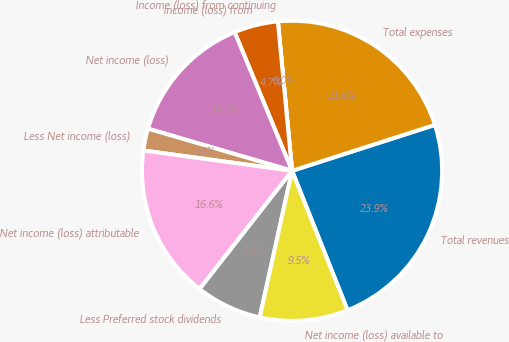Convert chart to OTSL. <chart><loc_0><loc_0><loc_500><loc_500><pie_chart><fcel>Total revenues<fcel>Total expenses<fcel>Income (loss) from continuing<fcel>Income (loss) from<fcel>Net income (loss)<fcel>Less Net income (loss)<fcel>Net income (loss) attributable<fcel>Less Preferred stock dividends<fcel>Net income (loss) available to<nl><fcel>23.92%<fcel>21.55%<fcel>0.0%<fcel>4.74%<fcel>14.22%<fcel>2.37%<fcel>16.59%<fcel>7.11%<fcel>9.48%<nl></chart> 